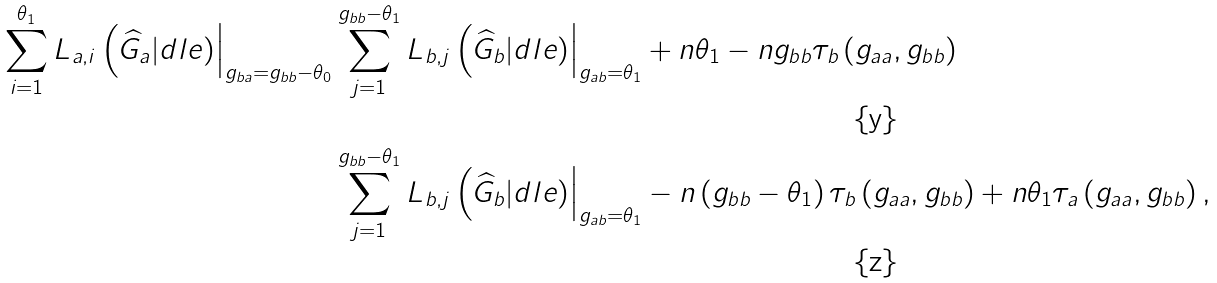Convert formula to latex. <formula><loc_0><loc_0><loc_500><loc_500>\sum _ { i = 1 } ^ { \theta _ { 1 } } L _ { a , i } \left ( \widehat { G } _ { a } | d l e ) \right | _ { g _ { b a } = g _ { b b } - \theta _ { 0 } } & \sum _ { j = 1 } ^ { g _ { b b } - \theta _ { 1 } } L _ { b , j } \left ( \widehat { G } _ { b } | d l e ) \right | _ { g _ { a b } = \theta _ { 1 } } + n \theta _ { 1 } - n g _ { b b } \tau _ { b } \left ( g _ { a a } , g _ { b b } \right ) \\ & \sum _ { j = 1 } ^ { g _ { b b } - \theta _ { 1 } } L _ { b , j } \left ( \widehat { G } _ { b } | d l e ) \right | _ { g _ { a b } = \theta _ { 1 } } - n \left ( g _ { b b } - \theta _ { 1 } \right ) \tau _ { b } \left ( g _ { a a } , g _ { b b } \right ) + n \theta _ { 1 } \tau _ { a } \left ( g _ { a a } , g _ { b b } \right ) ,</formula> 